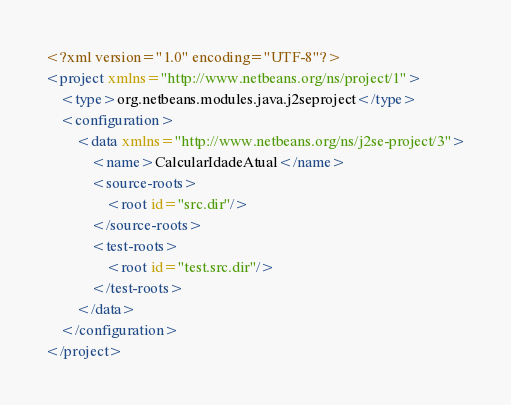Convert code to text. <code><loc_0><loc_0><loc_500><loc_500><_XML_><?xml version="1.0" encoding="UTF-8"?>
<project xmlns="http://www.netbeans.org/ns/project/1">
    <type>org.netbeans.modules.java.j2seproject</type>
    <configuration>
        <data xmlns="http://www.netbeans.org/ns/j2se-project/3">
            <name>CalcularIdadeAtual</name>
            <source-roots>
                <root id="src.dir"/>
            </source-roots>
            <test-roots>
                <root id="test.src.dir"/>
            </test-roots>
        </data>
    </configuration>
</project>
</code> 